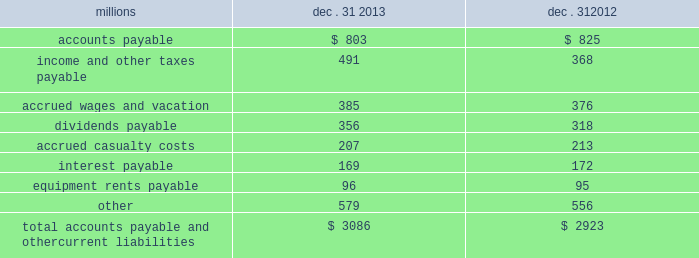The analysis of our depreciation studies .
Changes in the estimated service lives of our assets and their related depreciation rates are implemented prospectively .
Under group depreciation , the historical cost ( net of salvage ) of depreciable property that is retired or replaced in the ordinary course of business is charged to accumulated depreciation and no gain or loss is recognized .
The historical cost of certain track assets is estimated using ( i ) inflation indices published by the bureau of labor statistics and ( ii ) the estimated useful lives of the assets as determined by our depreciation studies .
The indices were selected because they closely correlate with the major costs of the properties comprising the applicable track asset classes .
Because of the number of estimates inherent in the depreciation and retirement processes and because it is impossible to precisely estimate each of these variables until a group of property is completely retired , we continually monitor the estimated service lives of our assets and the accumulated depreciation associated with each asset class to ensure our depreciation rates are appropriate .
In addition , we determine if the recorded amount of accumulated depreciation is deficient ( or in excess ) of the amount indicated by our depreciation studies .
Any deficiency ( or excess ) is amortized as a component of depreciation expense over the remaining service lives of the applicable classes of assets .
For retirements of depreciable railroad properties that do not occur in the normal course of business , a gain or loss may be recognized if the retirement meets each of the following three conditions : ( i ) is unusual , ( ii ) is material in amount , and ( iii ) varies significantly from the retirement profile identified through our depreciation studies .
A gain or loss is recognized in other income when we sell land or dispose of assets that are not part of our railroad operations .
When we purchase an asset , we capitalize all costs necessary to make the asset ready for its intended use .
However , many of our assets are self-constructed .
A large portion of our capital expenditures is for replacement of existing track assets and other road properties , which is typically performed by our employees , and for track line expansion and other capacity projects .
Costs that are directly attributable to capital projects ( including overhead costs ) are capitalized .
Direct costs that are capitalized as part of self- constructed assets include material , labor , and work equipment .
Indirect costs are capitalized if they clearly relate to the construction of the asset .
General and administrative expenditures are expensed as incurred .
Normal repairs and maintenance are also expensed as incurred , while costs incurred that extend the useful life of an asset , improve the safety of our operations or improve operating efficiency are capitalized .
These costs are allocated using appropriate statistical bases .
Total expense for repairs and maintenance incurred was $ 2.3 billion for 2013 , $ 2.1 billion for 2012 , and $ 2.2 billion for 2011 .
Assets held under capital leases are recorded at the lower of the net present value of the minimum lease payments or the fair value of the leased asset at the inception of the lease .
Amortization expense is computed using the straight-line method over the shorter of the estimated useful lives of the assets or the period of the related lease .
12 .
Accounts payable and other current liabilities dec .
31 , dec .
31 , millions 2013 2012 .

What was the percentage change in total expense for repairs and maintenance from 2011 to 2012? 
Computations: ((2.1 - 2.2) / 2.2)
Answer: -0.04545. 